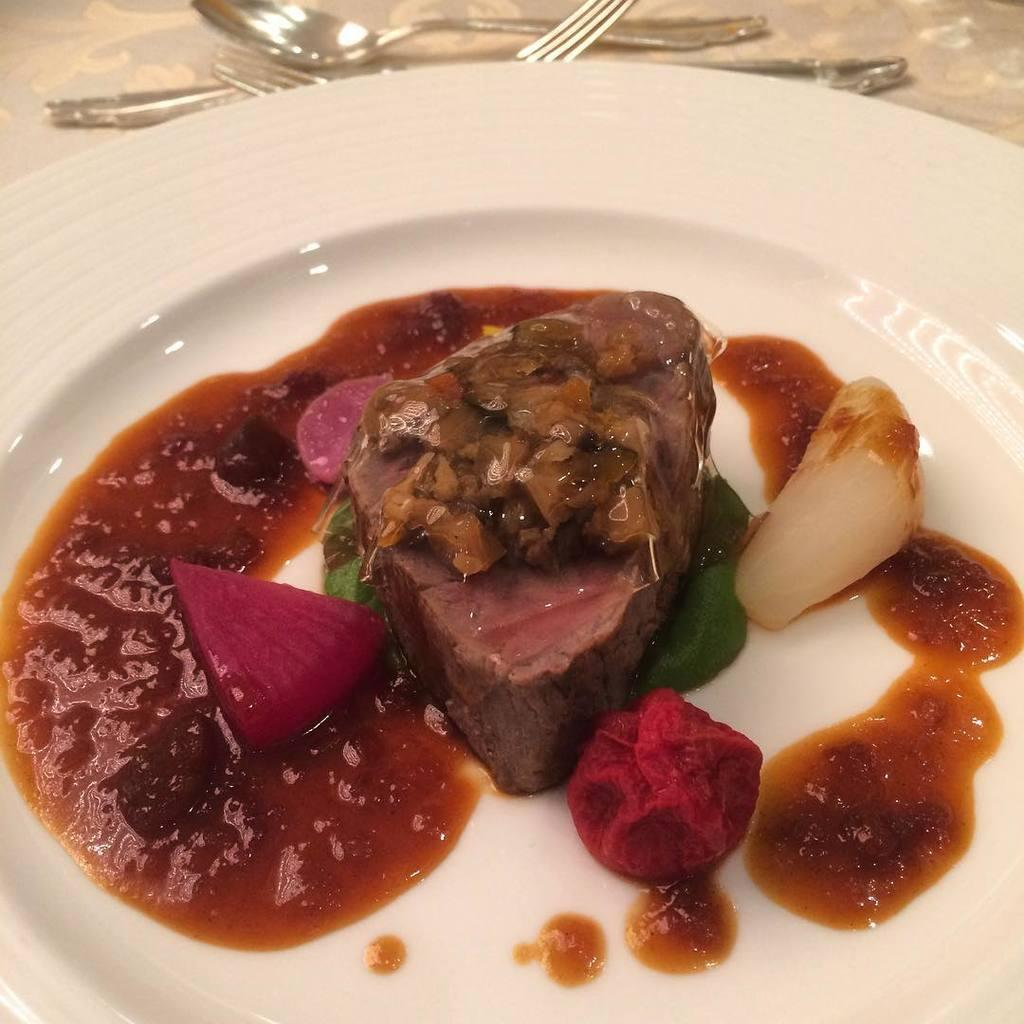What is on the plate that is visible in the image? There is food on a plate in the image. Where is the plate located in the image? The plate is placed on a table in the image. What utensils are present in front of the plate? Spoons and forks are in front of the plate in the image. Where is the nest located in the image? There is no nest present in the image. What type of road can be seen in the image? There is no road visible in the image. 